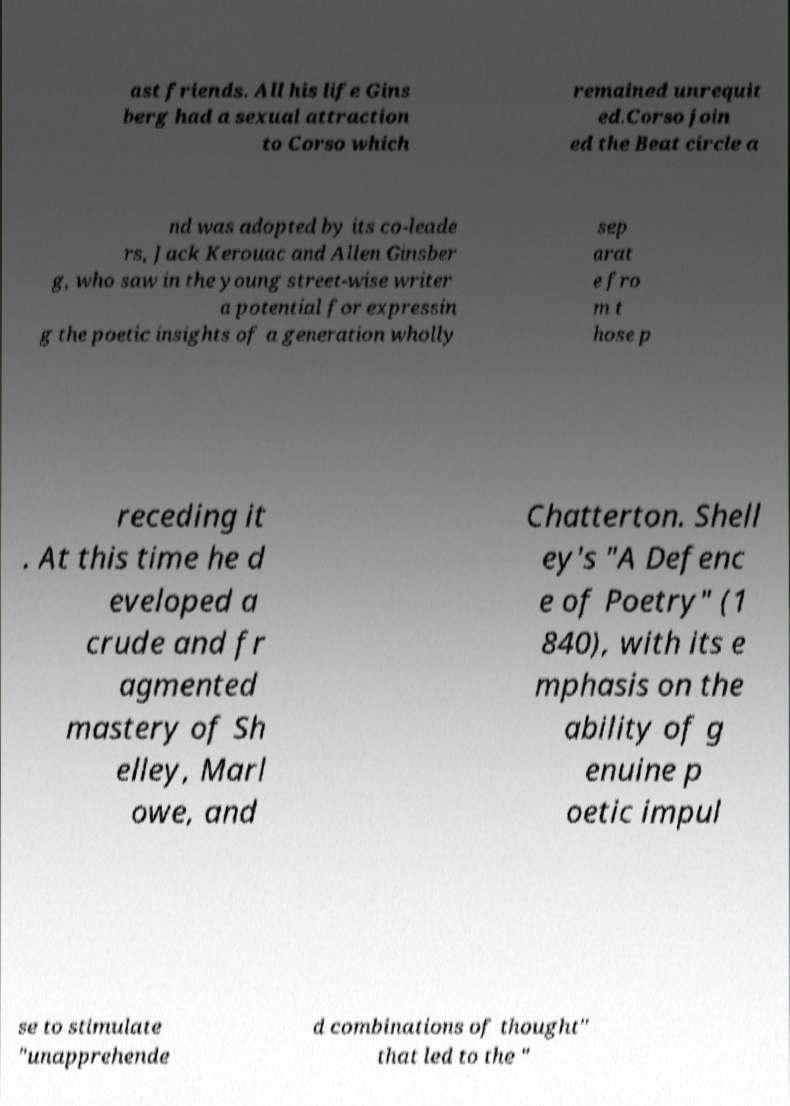Please identify and transcribe the text found in this image. ast friends. All his life Gins berg had a sexual attraction to Corso which remained unrequit ed.Corso join ed the Beat circle a nd was adopted by its co-leade rs, Jack Kerouac and Allen Ginsber g, who saw in the young street-wise writer a potential for expressin g the poetic insights of a generation wholly sep arat e fro m t hose p receding it . At this time he d eveloped a crude and fr agmented mastery of Sh elley, Marl owe, and Chatterton. Shell ey's "A Defenc e of Poetry" (1 840), with its e mphasis on the ability of g enuine p oetic impul se to stimulate "unapprehende d combinations of thought" that led to the " 